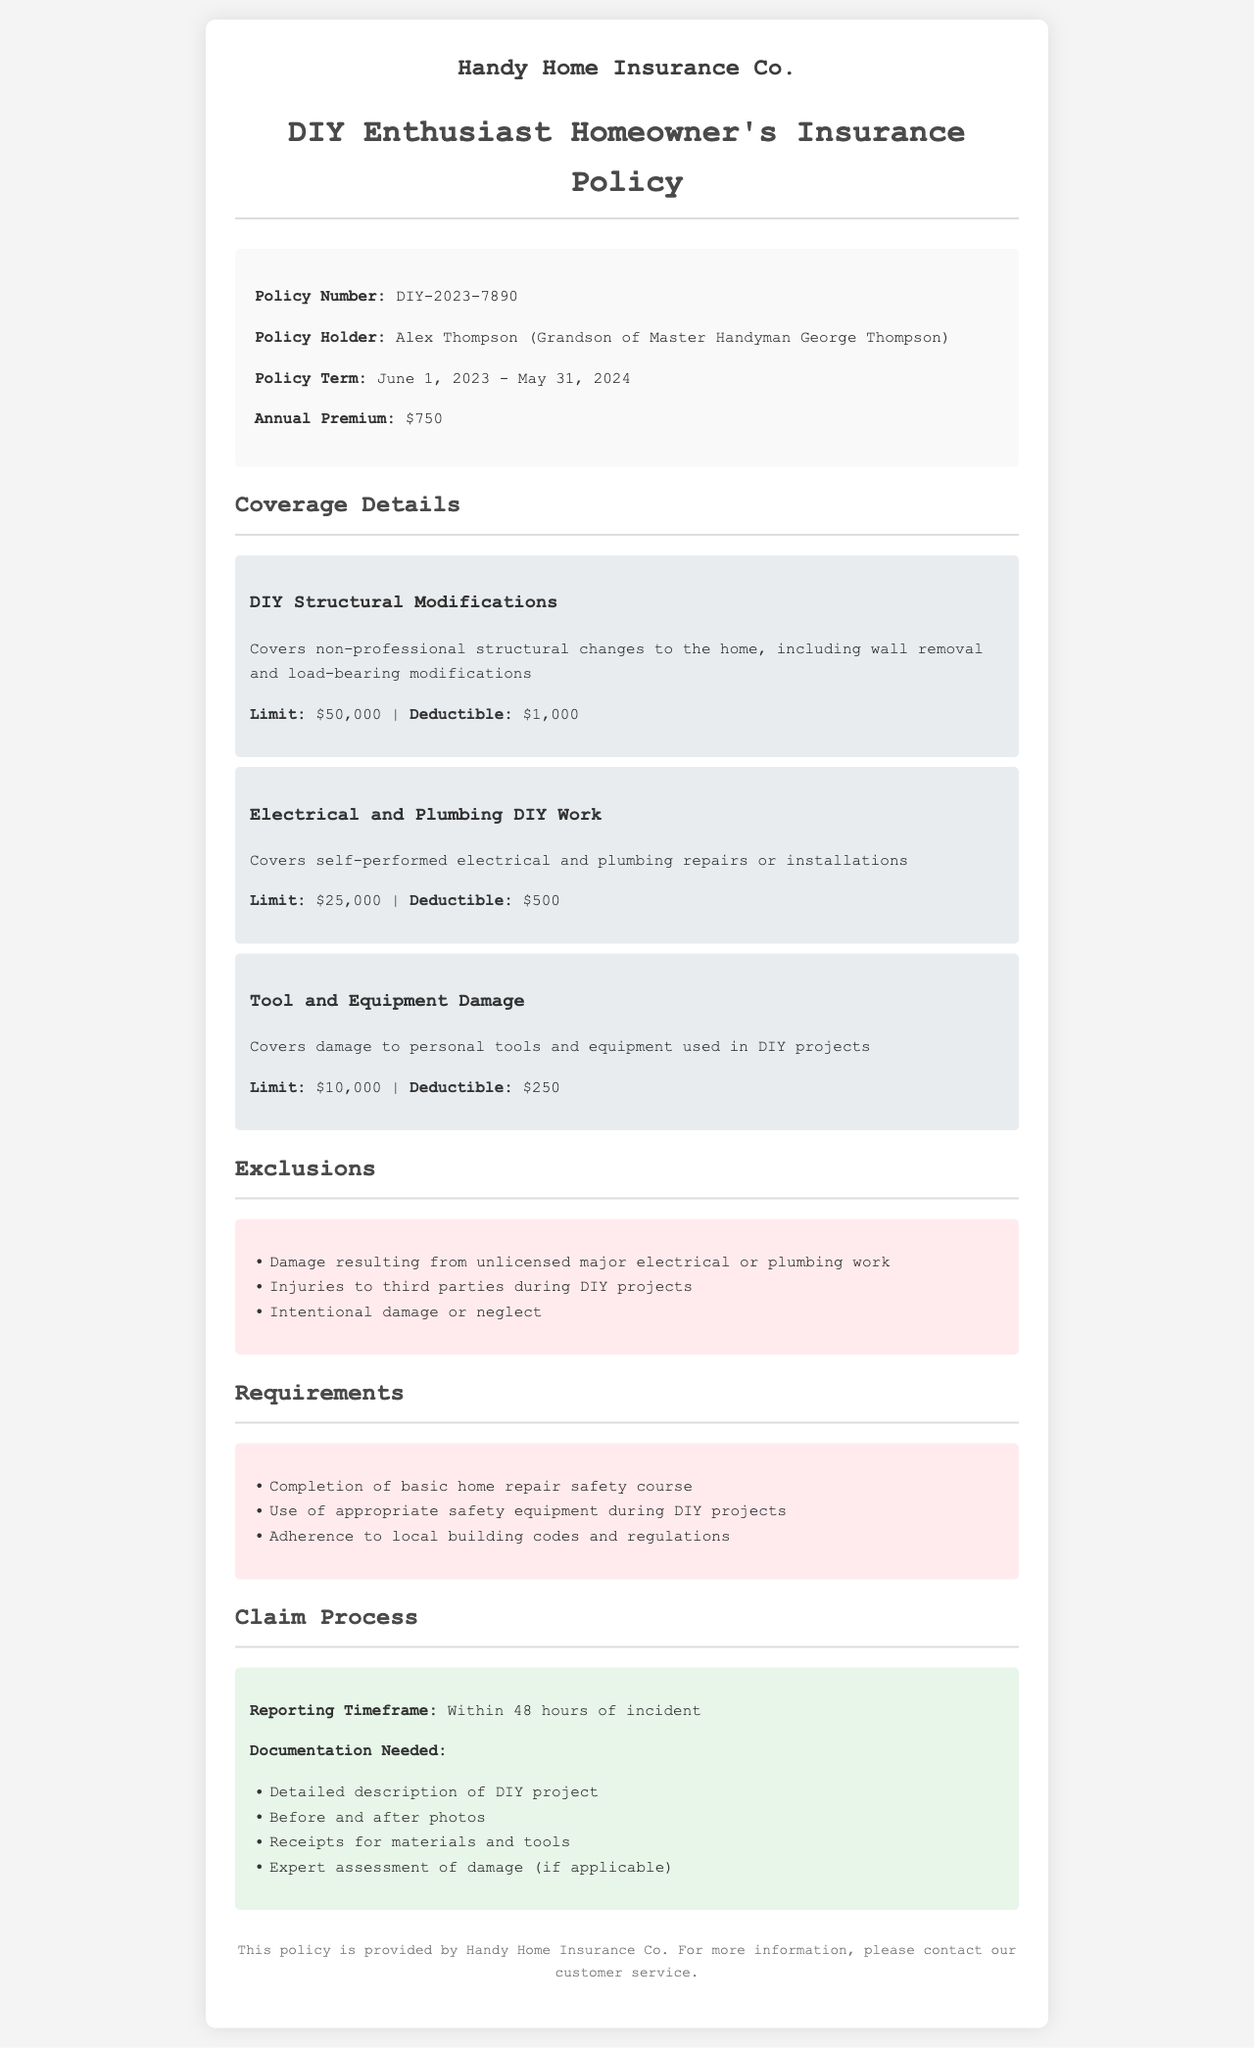What is the policy number? The policy number is listed in the policy details section.
Answer: DIY-2023-7890 Who is the policy holder? The policy holder's name is specified in the policy details section.
Answer: Alex Thompson (Grandson of Master Handyman George Thompson) What is the annual premium? The annual premium is mentioned in the policy details section.
Answer: $750 What is the limit for DIY Structural Modifications? The limit for DIY Structural Modifications is stated in the coverage details section.
Answer: $50,000 What type of work is excluded from coverage? The exclusions section lists the types of work not covered under the policy.
Answer: Damage resulting from unlicensed major electrical or plumbing work How long do you have to report an incident? The claim process section specifies the reporting timeframe for incidents.
Answer: Within 48 hours What is a requirement for this policy? The requirements section outlines necessary steps for eligibility.
Answer: Completion of basic home repair safety course What is the deductible for Tool and Equipment Damage? The deductible for Tool and Equipment Damage is found in the coverage details section.
Answer: $250 